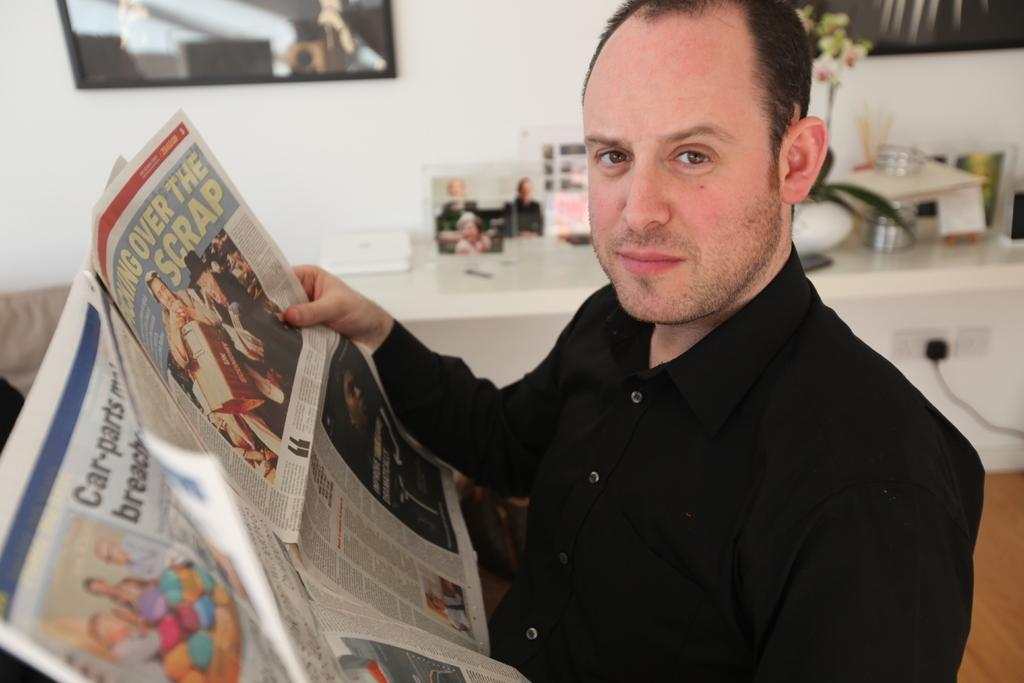<image>
Render a clear and concise summary of the photo. A man reading a newspaper with the headline over the scrap 